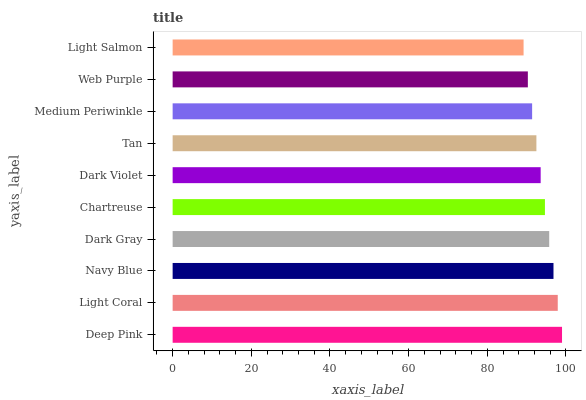Is Light Salmon the minimum?
Answer yes or no. Yes. Is Deep Pink the maximum?
Answer yes or no. Yes. Is Light Coral the minimum?
Answer yes or no. No. Is Light Coral the maximum?
Answer yes or no. No. Is Deep Pink greater than Light Coral?
Answer yes or no. Yes. Is Light Coral less than Deep Pink?
Answer yes or no. Yes. Is Light Coral greater than Deep Pink?
Answer yes or no. No. Is Deep Pink less than Light Coral?
Answer yes or no. No. Is Chartreuse the high median?
Answer yes or no. Yes. Is Dark Violet the low median?
Answer yes or no. Yes. Is Navy Blue the high median?
Answer yes or no. No. Is Chartreuse the low median?
Answer yes or no. No. 